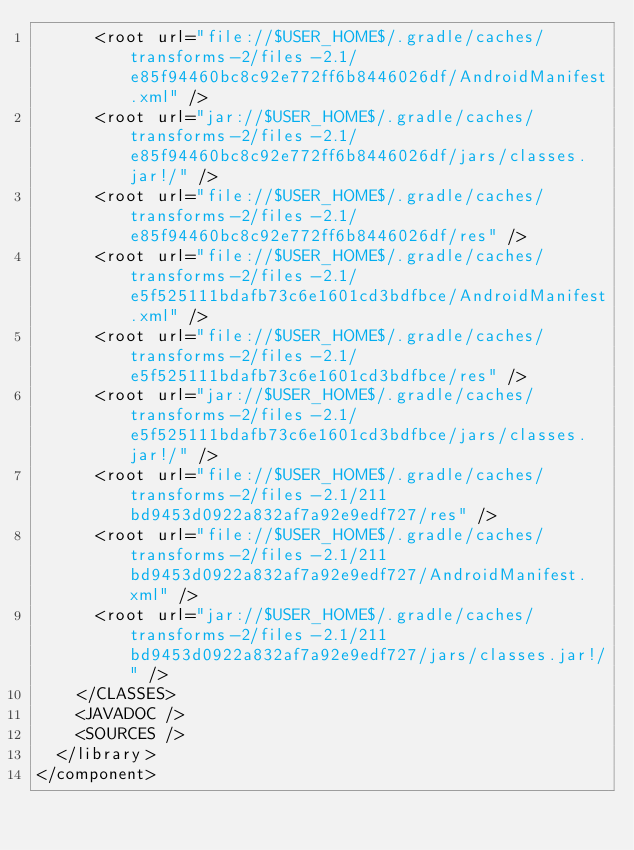<code> <loc_0><loc_0><loc_500><loc_500><_XML_>      <root url="file://$USER_HOME$/.gradle/caches/transforms-2/files-2.1/e85f94460bc8c92e772ff6b8446026df/AndroidManifest.xml" />
      <root url="jar://$USER_HOME$/.gradle/caches/transforms-2/files-2.1/e85f94460bc8c92e772ff6b8446026df/jars/classes.jar!/" />
      <root url="file://$USER_HOME$/.gradle/caches/transforms-2/files-2.1/e85f94460bc8c92e772ff6b8446026df/res" />
      <root url="file://$USER_HOME$/.gradle/caches/transforms-2/files-2.1/e5f525111bdafb73c6e1601cd3bdfbce/AndroidManifest.xml" />
      <root url="file://$USER_HOME$/.gradle/caches/transforms-2/files-2.1/e5f525111bdafb73c6e1601cd3bdfbce/res" />
      <root url="jar://$USER_HOME$/.gradle/caches/transforms-2/files-2.1/e5f525111bdafb73c6e1601cd3bdfbce/jars/classes.jar!/" />
      <root url="file://$USER_HOME$/.gradle/caches/transforms-2/files-2.1/211bd9453d0922a832af7a92e9edf727/res" />
      <root url="file://$USER_HOME$/.gradle/caches/transforms-2/files-2.1/211bd9453d0922a832af7a92e9edf727/AndroidManifest.xml" />
      <root url="jar://$USER_HOME$/.gradle/caches/transforms-2/files-2.1/211bd9453d0922a832af7a92e9edf727/jars/classes.jar!/" />
    </CLASSES>
    <JAVADOC />
    <SOURCES />
  </library>
</component></code> 